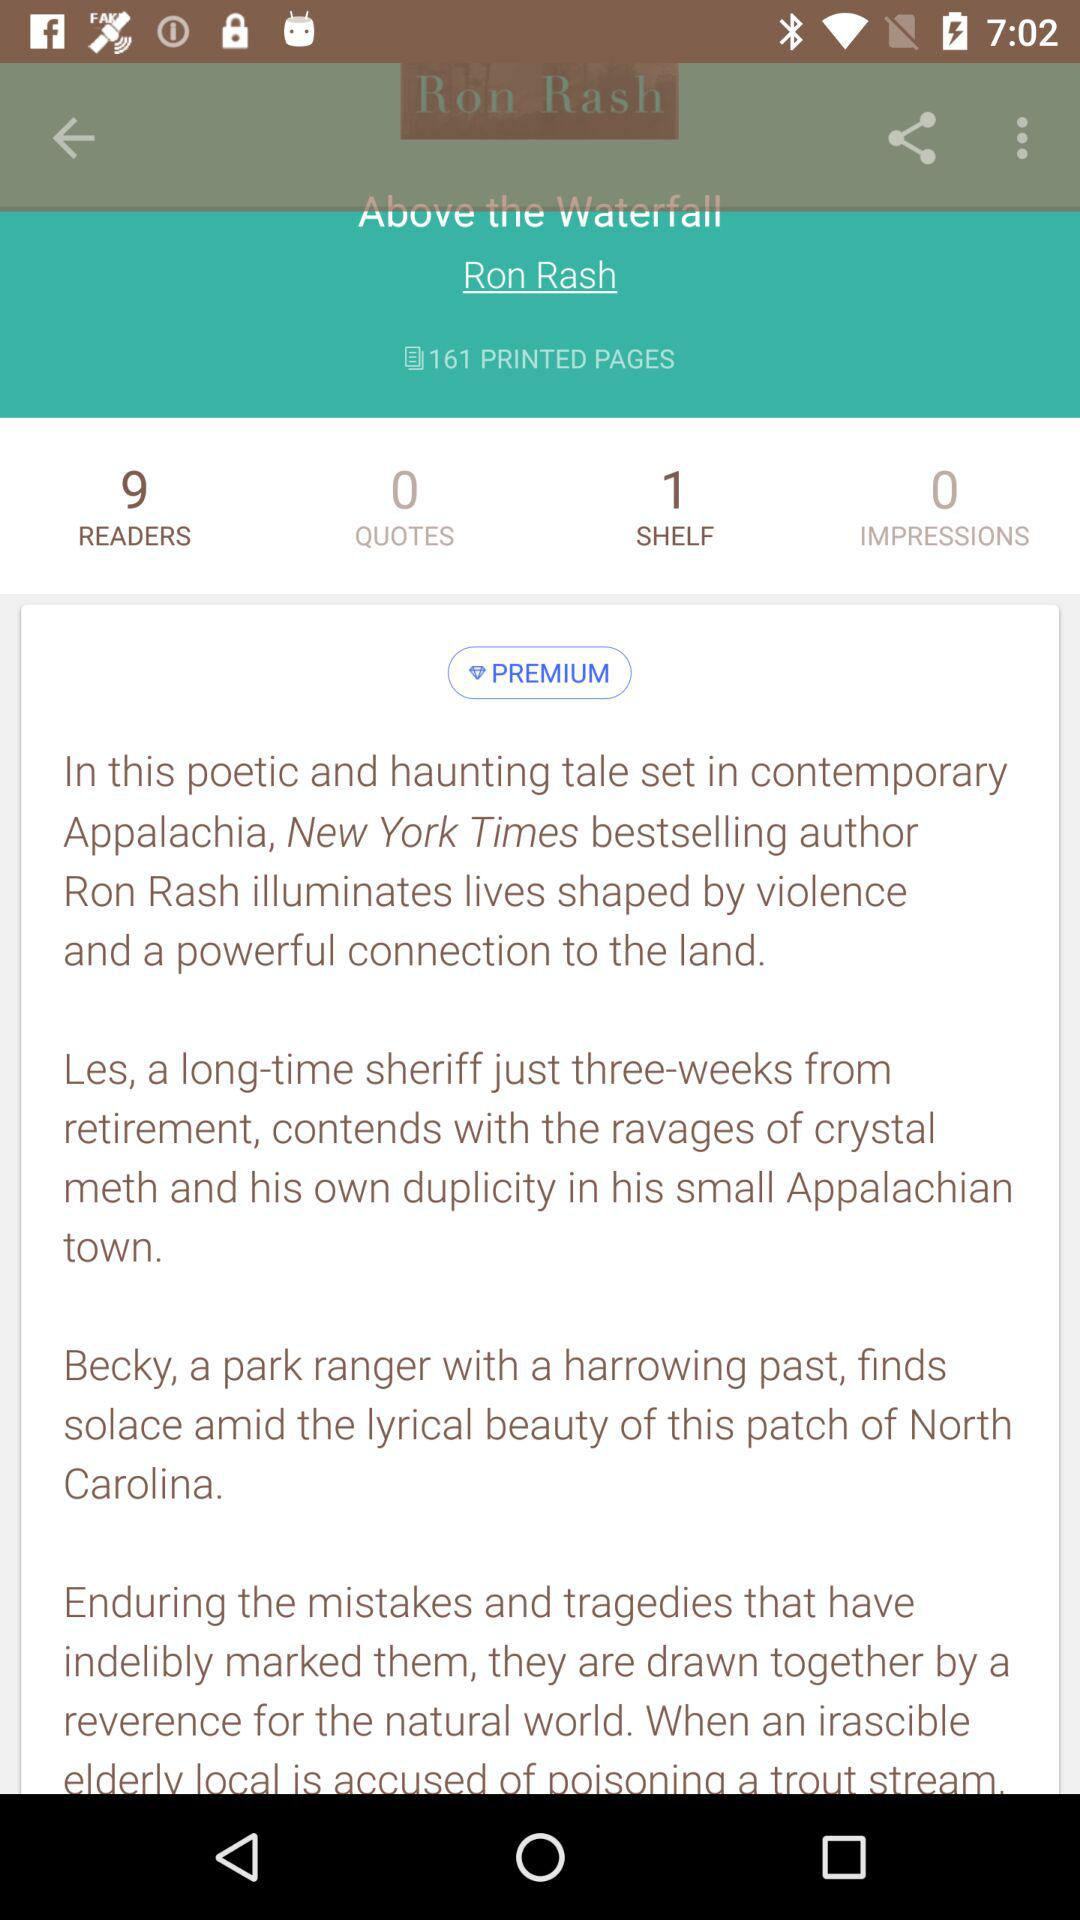What is the title? The title is "Above the Waterfall". 